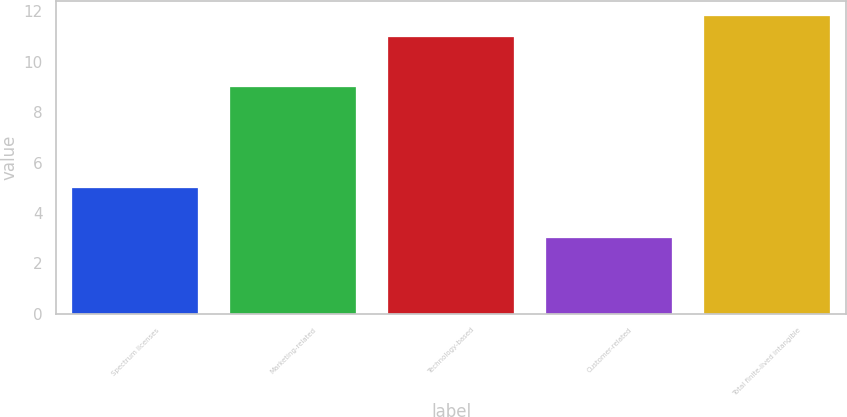<chart> <loc_0><loc_0><loc_500><loc_500><bar_chart><fcel>Spectrum licenses<fcel>Marketing-related<fcel>Technology-based<fcel>Customer-related<fcel>Total finite-lived intangible<nl><fcel>5<fcel>9<fcel>11<fcel>3<fcel>11.8<nl></chart> 